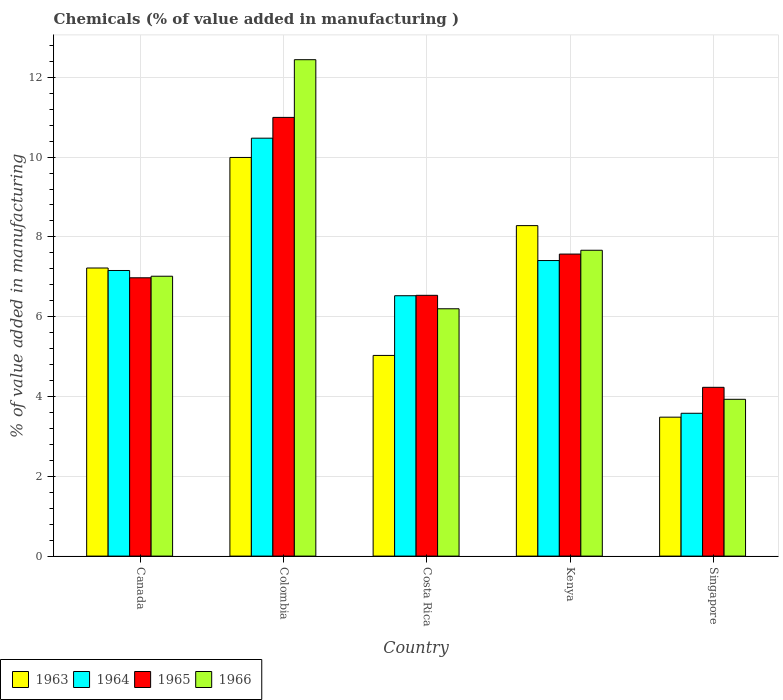How many groups of bars are there?
Your answer should be very brief. 5. Are the number of bars on each tick of the X-axis equal?
Your answer should be compact. Yes. How many bars are there on the 4th tick from the right?
Provide a short and direct response. 4. What is the label of the 5th group of bars from the left?
Offer a terse response. Singapore. In how many cases, is the number of bars for a given country not equal to the number of legend labels?
Your answer should be compact. 0. What is the value added in manufacturing chemicals in 1964 in Canada?
Your answer should be compact. 7.16. Across all countries, what is the maximum value added in manufacturing chemicals in 1966?
Ensure brevity in your answer.  12.44. Across all countries, what is the minimum value added in manufacturing chemicals in 1966?
Your response must be concise. 3.93. In which country was the value added in manufacturing chemicals in 1963 minimum?
Keep it short and to the point. Singapore. What is the total value added in manufacturing chemicals in 1964 in the graph?
Keep it short and to the point. 35.15. What is the difference between the value added in manufacturing chemicals in 1965 in Costa Rica and that in Kenya?
Your answer should be compact. -1.03. What is the difference between the value added in manufacturing chemicals in 1963 in Costa Rica and the value added in manufacturing chemicals in 1965 in Colombia?
Keep it short and to the point. -5.97. What is the average value added in manufacturing chemicals in 1964 per country?
Offer a very short reply. 7.03. What is the difference between the value added in manufacturing chemicals of/in 1963 and value added in manufacturing chemicals of/in 1966 in Singapore?
Your response must be concise. -0.45. In how many countries, is the value added in manufacturing chemicals in 1965 greater than 11.2 %?
Your answer should be compact. 0. What is the ratio of the value added in manufacturing chemicals in 1966 in Kenya to that in Singapore?
Provide a short and direct response. 1.95. Is the value added in manufacturing chemicals in 1966 in Colombia less than that in Singapore?
Provide a succinct answer. No. Is the difference between the value added in manufacturing chemicals in 1963 in Canada and Colombia greater than the difference between the value added in manufacturing chemicals in 1966 in Canada and Colombia?
Your answer should be very brief. Yes. What is the difference between the highest and the second highest value added in manufacturing chemicals in 1966?
Make the answer very short. -5.43. What is the difference between the highest and the lowest value added in manufacturing chemicals in 1963?
Keep it short and to the point. 6.51. In how many countries, is the value added in manufacturing chemicals in 1965 greater than the average value added in manufacturing chemicals in 1965 taken over all countries?
Offer a terse response. 2. Is the sum of the value added in manufacturing chemicals in 1964 in Kenya and Singapore greater than the maximum value added in manufacturing chemicals in 1966 across all countries?
Your response must be concise. No. What does the 3rd bar from the left in Kenya represents?
Your response must be concise. 1965. What does the 2nd bar from the right in Singapore represents?
Keep it short and to the point. 1965. How many bars are there?
Keep it short and to the point. 20. What is the difference between two consecutive major ticks on the Y-axis?
Your answer should be very brief. 2. Are the values on the major ticks of Y-axis written in scientific E-notation?
Offer a terse response. No. Does the graph contain any zero values?
Give a very brief answer. No. Does the graph contain grids?
Provide a succinct answer. Yes. What is the title of the graph?
Your answer should be compact. Chemicals (% of value added in manufacturing ). Does "1972" appear as one of the legend labels in the graph?
Your answer should be compact. No. What is the label or title of the X-axis?
Make the answer very short. Country. What is the label or title of the Y-axis?
Keep it short and to the point. % of value added in manufacturing. What is the % of value added in manufacturing of 1963 in Canada?
Provide a succinct answer. 7.22. What is the % of value added in manufacturing of 1964 in Canada?
Your response must be concise. 7.16. What is the % of value added in manufacturing of 1965 in Canada?
Your answer should be compact. 6.98. What is the % of value added in manufacturing of 1966 in Canada?
Ensure brevity in your answer.  7.01. What is the % of value added in manufacturing of 1963 in Colombia?
Your response must be concise. 9.99. What is the % of value added in manufacturing in 1964 in Colombia?
Give a very brief answer. 10.47. What is the % of value added in manufacturing in 1965 in Colombia?
Your answer should be very brief. 10.99. What is the % of value added in manufacturing of 1966 in Colombia?
Give a very brief answer. 12.44. What is the % of value added in manufacturing in 1963 in Costa Rica?
Your response must be concise. 5.03. What is the % of value added in manufacturing in 1964 in Costa Rica?
Give a very brief answer. 6.53. What is the % of value added in manufacturing of 1965 in Costa Rica?
Your answer should be compact. 6.54. What is the % of value added in manufacturing in 1966 in Costa Rica?
Your answer should be compact. 6.2. What is the % of value added in manufacturing in 1963 in Kenya?
Make the answer very short. 8.28. What is the % of value added in manufacturing in 1964 in Kenya?
Your answer should be compact. 7.41. What is the % of value added in manufacturing in 1965 in Kenya?
Keep it short and to the point. 7.57. What is the % of value added in manufacturing of 1966 in Kenya?
Make the answer very short. 7.67. What is the % of value added in manufacturing of 1963 in Singapore?
Ensure brevity in your answer.  3.48. What is the % of value added in manufacturing of 1964 in Singapore?
Your answer should be very brief. 3.58. What is the % of value added in manufacturing of 1965 in Singapore?
Give a very brief answer. 4.23. What is the % of value added in manufacturing in 1966 in Singapore?
Provide a succinct answer. 3.93. Across all countries, what is the maximum % of value added in manufacturing of 1963?
Provide a succinct answer. 9.99. Across all countries, what is the maximum % of value added in manufacturing of 1964?
Your response must be concise. 10.47. Across all countries, what is the maximum % of value added in manufacturing in 1965?
Your response must be concise. 10.99. Across all countries, what is the maximum % of value added in manufacturing in 1966?
Offer a terse response. 12.44. Across all countries, what is the minimum % of value added in manufacturing of 1963?
Your answer should be compact. 3.48. Across all countries, what is the minimum % of value added in manufacturing in 1964?
Make the answer very short. 3.58. Across all countries, what is the minimum % of value added in manufacturing of 1965?
Make the answer very short. 4.23. Across all countries, what is the minimum % of value added in manufacturing in 1966?
Give a very brief answer. 3.93. What is the total % of value added in manufacturing of 1963 in the graph?
Provide a succinct answer. 34.01. What is the total % of value added in manufacturing of 1964 in the graph?
Make the answer very short. 35.15. What is the total % of value added in manufacturing of 1965 in the graph?
Ensure brevity in your answer.  36.31. What is the total % of value added in manufacturing in 1966 in the graph?
Ensure brevity in your answer.  37.25. What is the difference between the % of value added in manufacturing in 1963 in Canada and that in Colombia?
Your answer should be very brief. -2.77. What is the difference between the % of value added in manufacturing in 1964 in Canada and that in Colombia?
Ensure brevity in your answer.  -3.32. What is the difference between the % of value added in manufacturing in 1965 in Canada and that in Colombia?
Keep it short and to the point. -4.02. What is the difference between the % of value added in manufacturing of 1966 in Canada and that in Colombia?
Ensure brevity in your answer.  -5.43. What is the difference between the % of value added in manufacturing of 1963 in Canada and that in Costa Rica?
Offer a very short reply. 2.19. What is the difference between the % of value added in manufacturing in 1964 in Canada and that in Costa Rica?
Your response must be concise. 0.63. What is the difference between the % of value added in manufacturing of 1965 in Canada and that in Costa Rica?
Your answer should be very brief. 0.44. What is the difference between the % of value added in manufacturing in 1966 in Canada and that in Costa Rica?
Your answer should be compact. 0.82. What is the difference between the % of value added in manufacturing of 1963 in Canada and that in Kenya?
Make the answer very short. -1.06. What is the difference between the % of value added in manufacturing in 1964 in Canada and that in Kenya?
Your answer should be compact. -0.25. What is the difference between the % of value added in manufacturing in 1965 in Canada and that in Kenya?
Make the answer very short. -0.59. What is the difference between the % of value added in manufacturing in 1966 in Canada and that in Kenya?
Offer a terse response. -0.65. What is the difference between the % of value added in manufacturing in 1963 in Canada and that in Singapore?
Ensure brevity in your answer.  3.74. What is the difference between the % of value added in manufacturing of 1964 in Canada and that in Singapore?
Ensure brevity in your answer.  3.58. What is the difference between the % of value added in manufacturing of 1965 in Canada and that in Singapore?
Provide a succinct answer. 2.75. What is the difference between the % of value added in manufacturing of 1966 in Canada and that in Singapore?
Offer a terse response. 3.08. What is the difference between the % of value added in manufacturing in 1963 in Colombia and that in Costa Rica?
Keep it short and to the point. 4.96. What is the difference between the % of value added in manufacturing of 1964 in Colombia and that in Costa Rica?
Provide a succinct answer. 3.95. What is the difference between the % of value added in manufacturing in 1965 in Colombia and that in Costa Rica?
Offer a terse response. 4.46. What is the difference between the % of value added in manufacturing of 1966 in Colombia and that in Costa Rica?
Offer a terse response. 6.24. What is the difference between the % of value added in manufacturing in 1963 in Colombia and that in Kenya?
Your answer should be very brief. 1.71. What is the difference between the % of value added in manufacturing in 1964 in Colombia and that in Kenya?
Offer a terse response. 3.07. What is the difference between the % of value added in manufacturing in 1965 in Colombia and that in Kenya?
Keep it short and to the point. 3.43. What is the difference between the % of value added in manufacturing in 1966 in Colombia and that in Kenya?
Give a very brief answer. 4.78. What is the difference between the % of value added in manufacturing of 1963 in Colombia and that in Singapore?
Provide a short and direct response. 6.51. What is the difference between the % of value added in manufacturing in 1964 in Colombia and that in Singapore?
Give a very brief answer. 6.89. What is the difference between the % of value added in manufacturing in 1965 in Colombia and that in Singapore?
Offer a very short reply. 6.76. What is the difference between the % of value added in manufacturing of 1966 in Colombia and that in Singapore?
Make the answer very short. 8.51. What is the difference between the % of value added in manufacturing of 1963 in Costa Rica and that in Kenya?
Offer a very short reply. -3.25. What is the difference between the % of value added in manufacturing in 1964 in Costa Rica and that in Kenya?
Make the answer very short. -0.88. What is the difference between the % of value added in manufacturing in 1965 in Costa Rica and that in Kenya?
Give a very brief answer. -1.03. What is the difference between the % of value added in manufacturing in 1966 in Costa Rica and that in Kenya?
Your answer should be very brief. -1.47. What is the difference between the % of value added in manufacturing in 1963 in Costa Rica and that in Singapore?
Keep it short and to the point. 1.55. What is the difference between the % of value added in manufacturing of 1964 in Costa Rica and that in Singapore?
Offer a very short reply. 2.95. What is the difference between the % of value added in manufacturing in 1965 in Costa Rica and that in Singapore?
Offer a very short reply. 2.31. What is the difference between the % of value added in manufacturing in 1966 in Costa Rica and that in Singapore?
Offer a very short reply. 2.27. What is the difference between the % of value added in manufacturing in 1963 in Kenya and that in Singapore?
Ensure brevity in your answer.  4.8. What is the difference between the % of value added in manufacturing of 1964 in Kenya and that in Singapore?
Keep it short and to the point. 3.83. What is the difference between the % of value added in manufacturing in 1965 in Kenya and that in Singapore?
Offer a terse response. 3.34. What is the difference between the % of value added in manufacturing of 1966 in Kenya and that in Singapore?
Your answer should be compact. 3.74. What is the difference between the % of value added in manufacturing of 1963 in Canada and the % of value added in manufacturing of 1964 in Colombia?
Your answer should be compact. -3.25. What is the difference between the % of value added in manufacturing of 1963 in Canada and the % of value added in manufacturing of 1965 in Colombia?
Make the answer very short. -3.77. What is the difference between the % of value added in manufacturing in 1963 in Canada and the % of value added in manufacturing in 1966 in Colombia?
Provide a short and direct response. -5.22. What is the difference between the % of value added in manufacturing of 1964 in Canada and the % of value added in manufacturing of 1965 in Colombia?
Your answer should be very brief. -3.84. What is the difference between the % of value added in manufacturing in 1964 in Canada and the % of value added in manufacturing in 1966 in Colombia?
Your response must be concise. -5.28. What is the difference between the % of value added in manufacturing of 1965 in Canada and the % of value added in manufacturing of 1966 in Colombia?
Ensure brevity in your answer.  -5.47. What is the difference between the % of value added in manufacturing in 1963 in Canada and the % of value added in manufacturing in 1964 in Costa Rica?
Your answer should be compact. 0.69. What is the difference between the % of value added in manufacturing of 1963 in Canada and the % of value added in manufacturing of 1965 in Costa Rica?
Make the answer very short. 0.68. What is the difference between the % of value added in manufacturing of 1963 in Canada and the % of value added in manufacturing of 1966 in Costa Rica?
Keep it short and to the point. 1.02. What is the difference between the % of value added in manufacturing of 1964 in Canada and the % of value added in manufacturing of 1965 in Costa Rica?
Your response must be concise. 0.62. What is the difference between the % of value added in manufacturing of 1964 in Canada and the % of value added in manufacturing of 1966 in Costa Rica?
Your answer should be compact. 0.96. What is the difference between the % of value added in manufacturing of 1965 in Canada and the % of value added in manufacturing of 1966 in Costa Rica?
Keep it short and to the point. 0.78. What is the difference between the % of value added in manufacturing of 1963 in Canada and the % of value added in manufacturing of 1964 in Kenya?
Provide a short and direct response. -0.19. What is the difference between the % of value added in manufacturing of 1963 in Canada and the % of value added in manufacturing of 1965 in Kenya?
Offer a terse response. -0.35. What is the difference between the % of value added in manufacturing of 1963 in Canada and the % of value added in manufacturing of 1966 in Kenya?
Make the answer very short. -0.44. What is the difference between the % of value added in manufacturing in 1964 in Canada and the % of value added in manufacturing in 1965 in Kenya?
Offer a very short reply. -0.41. What is the difference between the % of value added in manufacturing of 1964 in Canada and the % of value added in manufacturing of 1966 in Kenya?
Make the answer very short. -0.51. What is the difference between the % of value added in manufacturing in 1965 in Canada and the % of value added in manufacturing in 1966 in Kenya?
Offer a terse response. -0.69. What is the difference between the % of value added in manufacturing of 1963 in Canada and the % of value added in manufacturing of 1964 in Singapore?
Ensure brevity in your answer.  3.64. What is the difference between the % of value added in manufacturing of 1963 in Canada and the % of value added in manufacturing of 1965 in Singapore?
Offer a very short reply. 2.99. What is the difference between the % of value added in manufacturing in 1963 in Canada and the % of value added in manufacturing in 1966 in Singapore?
Provide a succinct answer. 3.29. What is the difference between the % of value added in manufacturing of 1964 in Canada and the % of value added in manufacturing of 1965 in Singapore?
Keep it short and to the point. 2.93. What is the difference between the % of value added in manufacturing in 1964 in Canada and the % of value added in manufacturing in 1966 in Singapore?
Provide a short and direct response. 3.23. What is the difference between the % of value added in manufacturing in 1965 in Canada and the % of value added in manufacturing in 1966 in Singapore?
Provide a short and direct response. 3.05. What is the difference between the % of value added in manufacturing in 1963 in Colombia and the % of value added in manufacturing in 1964 in Costa Rica?
Offer a terse response. 3.47. What is the difference between the % of value added in manufacturing in 1963 in Colombia and the % of value added in manufacturing in 1965 in Costa Rica?
Keep it short and to the point. 3.46. What is the difference between the % of value added in manufacturing in 1963 in Colombia and the % of value added in manufacturing in 1966 in Costa Rica?
Your response must be concise. 3.79. What is the difference between the % of value added in manufacturing of 1964 in Colombia and the % of value added in manufacturing of 1965 in Costa Rica?
Provide a succinct answer. 3.94. What is the difference between the % of value added in manufacturing of 1964 in Colombia and the % of value added in manufacturing of 1966 in Costa Rica?
Give a very brief answer. 4.28. What is the difference between the % of value added in manufacturing of 1965 in Colombia and the % of value added in manufacturing of 1966 in Costa Rica?
Make the answer very short. 4.8. What is the difference between the % of value added in manufacturing of 1963 in Colombia and the % of value added in manufacturing of 1964 in Kenya?
Your answer should be very brief. 2.58. What is the difference between the % of value added in manufacturing in 1963 in Colombia and the % of value added in manufacturing in 1965 in Kenya?
Your answer should be very brief. 2.42. What is the difference between the % of value added in manufacturing in 1963 in Colombia and the % of value added in manufacturing in 1966 in Kenya?
Ensure brevity in your answer.  2.33. What is the difference between the % of value added in manufacturing of 1964 in Colombia and the % of value added in manufacturing of 1965 in Kenya?
Provide a succinct answer. 2.9. What is the difference between the % of value added in manufacturing in 1964 in Colombia and the % of value added in manufacturing in 1966 in Kenya?
Your answer should be compact. 2.81. What is the difference between the % of value added in manufacturing in 1965 in Colombia and the % of value added in manufacturing in 1966 in Kenya?
Offer a terse response. 3.33. What is the difference between the % of value added in manufacturing in 1963 in Colombia and the % of value added in manufacturing in 1964 in Singapore?
Your answer should be very brief. 6.41. What is the difference between the % of value added in manufacturing of 1963 in Colombia and the % of value added in manufacturing of 1965 in Singapore?
Your response must be concise. 5.76. What is the difference between the % of value added in manufacturing of 1963 in Colombia and the % of value added in manufacturing of 1966 in Singapore?
Offer a very short reply. 6.06. What is the difference between the % of value added in manufacturing in 1964 in Colombia and the % of value added in manufacturing in 1965 in Singapore?
Offer a very short reply. 6.24. What is the difference between the % of value added in manufacturing in 1964 in Colombia and the % of value added in manufacturing in 1966 in Singapore?
Give a very brief answer. 6.54. What is the difference between the % of value added in manufacturing of 1965 in Colombia and the % of value added in manufacturing of 1966 in Singapore?
Keep it short and to the point. 7.07. What is the difference between the % of value added in manufacturing of 1963 in Costa Rica and the % of value added in manufacturing of 1964 in Kenya?
Ensure brevity in your answer.  -2.38. What is the difference between the % of value added in manufacturing of 1963 in Costa Rica and the % of value added in manufacturing of 1965 in Kenya?
Your response must be concise. -2.54. What is the difference between the % of value added in manufacturing of 1963 in Costa Rica and the % of value added in manufacturing of 1966 in Kenya?
Your answer should be very brief. -2.64. What is the difference between the % of value added in manufacturing in 1964 in Costa Rica and the % of value added in manufacturing in 1965 in Kenya?
Your answer should be very brief. -1.04. What is the difference between the % of value added in manufacturing in 1964 in Costa Rica and the % of value added in manufacturing in 1966 in Kenya?
Your response must be concise. -1.14. What is the difference between the % of value added in manufacturing of 1965 in Costa Rica and the % of value added in manufacturing of 1966 in Kenya?
Provide a short and direct response. -1.13. What is the difference between the % of value added in manufacturing in 1963 in Costa Rica and the % of value added in manufacturing in 1964 in Singapore?
Ensure brevity in your answer.  1.45. What is the difference between the % of value added in manufacturing of 1963 in Costa Rica and the % of value added in manufacturing of 1965 in Singapore?
Your answer should be compact. 0.8. What is the difference between the % of value added in manufacturing in 1963 in Costa Rica and the % of value added in manufacturing in 1966 in Singapore?
Ensure brevity in your answer.  1.1. What is the difference between the % of value added in manufacturing in 1964 in Costa Rica and the % of value added in manufacturing in 1965 in Singapore?
Provide a succinct answer. 2.3. What is the difference between the % of value added in manufacturing in 1964 in Costa Rica and the % of value added in manufacturing in 1966 in Singapore?
Ensure brevity in your answer.  2.6. What is the difference between the % of value added in manufacturing of 1965 in Costa Rica and the % of value added in manufacturing of 1966 in Singapore?
Give a very brief answer. 2.61. What is the difference between the % of value added in manufacturing of 1963 in Kenya and the % of value added in manufacturing of 1964 in Singapore?
Your answer should be compact. 4.7. What is the difference between the % of value added in manufacturing in 1963 in Kenya and the % of value added in manufacturing in 1965 in Singapore?
Offer a terse response. 4.05. What is the difference between the % of value added in manufacturing in 1963 in Kenya and the % of value added in manufacturing in 1966 in Singapore?
Your answer should be very brief. 4.35. What is the difference between the % of value added in manufacturing of 1964 in Kenya and the % of value added in manufacturing of 1965 in Singapore?
Your response must be concise. 3.18. What is the difference between the % of value added in manufacturing of 1964 in Kenya and the % of value added in manufacturing of 1966 in Singapore?
Provide a short and direct response. 3.48. What is the difference between the % of value added in manufacturing in 1965 in Kenya and the % of value added in manufacturing in 1966 in Singapore?
Provide a short and direct response. 3.64. What is the average % of value added in manufacturing of 1963 per country?
Your answer should be compact. 6.8. What is the average % of value added in manufacturing of 1964 per country?
Give a very brief answer. 7.03. What is the average % of value added in manufacturing of 1965 per country?
Ensure brevity in your answer.  7.26. What is the average % of value added in manufacturing of 1966 per country?
Give a very brief answer. 7.45. What is the difference between the % of value added in manufacturing of 1963 and % of value added in manufacturing of 1964 in Canada?
Your answer should be compact. 0.06. What is the difference between the % of value added in manufacturing in 1963 and % of value added in manufacturing in 1965 in Canada?
Keep it short and to the point. 0.25. What is the difference between the % of value added in manufacturing of 1963 and % of value added in manufacturing of 1966 in Canada?
Your answer should be compact. 0.21. What is the difference between the % of value added in manufacturing of 1964 and % of value added in manufacturing of 1965 in Canada?
Provide a succinct answer. 0.18. What is the difference between the % of value added in manufacturing in 1964 and % of value added in manufacturing in 1966 in Canada?
Provide a short and direct response. 0.14. What is the difference between the % of value added in manufacturing of 1965 and % of value added in manufacturing of 1966 in Canada?
Your answer should be very brief. -0.04. What is the difference between the % of value added in manufacturing of 1963 and % of value added in manufacturing of 1964 in Colombia?
Provide a short and direct response. -0.48. What is the difference between the % of value added in manufacturing of 1963 and % of value added in manufacturing of 1965 in Colombia?
Your answer should be compact. -1. What is the difference between the % of value added in manufacturing in 1963 and % of value added in manufacturing in 1966 in Colombia?
Provide a succinct answer. -2.45. What is the difference between the % of value added in manufacturing of 1964 and % of value added in manufacturing of 1965 in Colombia?
Provide a succinct answer. -0.52. What is the difference between the % of value added in manufacturing of 1964 and % of value added in manufacturing of 1966 in Colombia?
Offer a terse response. -1.97. What is the difference between the % of value added in manufacturing of 1965 and % of value added in manufacturing of 1966 in Colombia?
Your answer should be compact. -1.45. What is the difference between the % of value added in manufacturing of 1963 and % of value added in manufacturing of 1964 in Costa Rica?
Keep it short and to the point. -1.5. What is the difference between the % of value added in manufacturing in 1963 and % of value added in manufacturing in 1965 in Costa Rica?
Ensure brevity in your answer.  -1.51. What is the difference between the % of value added in manufacturing in 1963 and % of value added in manufacturing in 1966 in Costa Rica?
Offer a terse response. -1.17. What is the difference between the % of value added in manufacturing in 1964 and % of value added in manufacturing in 1965 in Costa Rica?
Your response must be concise. -0.01. What is the difference between the % of value added in manufacturing of 1964 and % of value added in manufacturing of 1966 in Costa Rica?
Make the answer very short. 0.33. What is the difference between the % of value added in manufacturing in 1965 and % of value added in manufacturing in 1966 in Costa Rica?
Ensure brevity in your answer.  0.34. What is the difference between the % of value added in manufacturing of 1963 and % of value added in manufacturing of 1964 in Kenya?
Keep it short and to the point. 0.87. What is the difference between the % of value added in manufacturing of 1963 and % of value added in manufacturing of 1965 in Kenya?
Make the answer very short. 0.71. What is the difference between the % of value added in manufacturing in 1963 and % of value added in manufacturing in 1966 in Kenya?
Provide a short and direct response. 0.62. What is the difference between the % of value added in manufacturing of 1964 and % of value added in manufacturing of 1965 in Kenya?
Keep it short and to the point. -0.16. What is the difference between the % of value added in manufacturing of 1964 and % of value added in manufacturing of 1966 in Kenya?
Make the answer very short. -0.26. What is the difference between the % of value added in manufacturing of 1965 and % of value added in manufacturing of 1966 in Kenya?
Give a very brief answer. -0.1. What is the difference between the % of value added in manufacturing of 1963 and % of value added in manufacturing of 1964 in Singapore?
Your answer should be compact. -0.1. What is the difference between the % of value added in manufacturing in 1963 and % of value added in manufacturing in 1965 in Singapore?
Give a very brief answer. -0.75. What is the difference between the % of value added in manufacturing of 1963 and % of value added in manufacturing of 1966 in Singapore?
Offer a terse response. -0.45. What is the difference between the % of value added in manufacturing of 1964 and % of value added in manufacturing of 1965 in Singapore?
Offer a terse response. -0.65. What is the difference between the % of value added in manufacturing in 1964 and % of value added in manufacturing in 1966 in Singapore?
Offer a terse response. -0.35. What is the difference between the % of value added in manufacturing of 1965 and % of value added in manufacturing of 1966 in Singapore?
Your response must be concise. 0.3. What is the ratio of the % of value added in manufacturing in 1963 in Canada to that in Colombia?
Provide a succinct answer. 0.72. What is the ratio of the % of value added in manufacturing in 1964 in Canada to that in Colombia?
Keep it short and to the point. 0.68. What is the ratio of the % of value added in manufacturing of 1965 in Canada to that in Colombia?
Your answer should be very brief. 0.63. What is the ratio of the % of value added in manufacturing in 1966 in Canada to that in Colombia?
Make the answer very short. 0.56. What is the ratio of the % of value added in manufacturing of 1963 in Canada to that in Costa Rica?
Keep it short and to the point. 1.44. What is the ratio of the % of value added in manufacturing in 1964 in Canada to that in Costa Rica?
Ensure brevity in your answer.  1.1. What is the ratio of the % of value added in manufacturing in 1965 in Canada to that in Costa Rica?
Offer a very short reply. 1.07. What is the ratio of the % of value added in manufacturing of 1966 in Canada to that in Costa Rica?
Offer a very short reply. 1.13. What is the ratio of the % of value added in manufacturing of 1963 in Canada to that in Kenya?
Provide a succinct answer. 0.87. What is the ratio of the % of value added in manufacturing in 1964 in Canada to that in Kenya?
Provide a succinct answer. 0.97. What is the ratio of the % of value added in manufacturing in 1965 in Canada to that in Kenya?
Offer a very short reply. 0.92. What is the ratio of the % of value added in manufacturing in 1966 in Canada to that in Kenya?
Ensure brevity in your answer.  0.92. What is the ratio of the % of value added in manufacturing of 1963 in Canada to that in Singapore?
Make the answer very short. 2.07. What is the ratio of the % of value added in manufacturing of 1964 in Canada to that in Singapore?
Provide a succinct answer. 2. What is the ratio of the % of value added in manufacturing of 1965 in Canada to that in Singapore?
Your answer should be very brief. 1.65. What is the ratio of the % of value added in manufacturing in 1966 in Canada to that in Singapore?
Your response must be concise. 1.78. What is the ratio of the % of value added in manufacturing in 1963 in Colombia to that in Costa Rica?
Provide a short and direct response. 1.99. What is the ratio of the % of value added in manufacturing of 1964 in Colombia to that in Costa Rica?
Ensure brevity in your answer.  1.61. What is the ratio of the % of value added in manufacturing of 1965 in Colombia to that in Costa Rica?
Keep it short and to the point. 1.68. What is the ratio of the % of value added in manufacturing of 1966 in Colombia to that in Costa Rica?
Your answer should be compact. 2.01. What is the ratio of the % of value added in manufacturing in 1963 in Colombia to that in Kenya?
Provide a succinct answer. 1.21. What is the ratio of the % of value added in manufacturing of 1964 in Colombia to that in Kenya?
Your response must be concise. 1.41. What is the ratio of the % of value added in manufacturing in 1965 in Colombia to that in Kenya?
Offer a terse response. 1.45. What is the ratio of the % of value added in manufacturing in 1966 in Colombia to that in Kenya?
Your answer should be compact. 1.62. What is the ratio of the % of value added in manufacturing in 1963 in Colombia to that in Singapore?
Give a very brief answer. 2.87. What is the ratio of the % of value added in manufacturing of 1964 in Colombia to that in Singapore?
Offer a terse response. 2.93. What is the ratio of the % of value added in manufacturing in 1965 in Colombia to that in Singapore?
Offer a very short reply. 2.6. What is the ratio of the % of value added in manufacturing in 1966 in Colombia to that in Singapore?
Keep it short and to the point. 3.17. What is the ratio of the % of value added in manufacturing in 1963 in Costa Rica to that in Kenya?
Keep it short and to the point. 0.61. What is the ratio of the % of value added in manufacturing of 1964 in Costa Rica to that in Kenya?
Your response must be concise. 0.88. What is the ratio of the % of value added in manufacturing in 1965 in Costa Rica to that in Kenya?
Provide a succinct answer. 0.86. What is the ratio of the % of value added in manufacturing of 1966 in Costa Rica to that in Kenya?
Provide a succinct answer. 0.81. What is the ratio of the % of value added in manufacturing of 1963 in Costa Rica to that in Singapore?
Your answer should be compact. 1.44. What is the ratio of the % of value added in manufacturing of 1964 in Costa Rica to that in Singapore?
Make the answer very short. 1.82. What is the ratio of the % of value added in manufacturing of 1965 in Costa Rica to that in Singapore?
Provide a short and direct response. 1.55. What is the ratio of the % of value added in manufacturing in 1966 in Costa Rica to that in Singapore?
Keep it short and to the point. 1.58. What is the ratio of the % of value added in manufacturing in 1963 in Kenya to that in Singapore?
Make the answer very short. 2.38. What is the ratio of the % of value added in manufacturing of 1964 in Kenya to that in Singapore?
Your answer should be very brief. 2.07. What is the ratio of the % of value added in manufacturing of 1965 in Kenya to that in Singapore?
Offer a terse response. 1.79. What is the ratio of the % of value added in manufacturing in 1966 in Kenya to that in Singapore?
Your answer should be compact. 1.95. What is the difference between the highest and the second highest % of value added in manufacturing in 1963?
Provide a short and direct response. 1.71. What is the difference between the highest and the second highest % of value added in manufacturing of 1964?
Your answer should be compact. 3.07. What is the difference between the highest and the second highest % of value added in manufacturing of 1965?
Offer a terse response. 3.43. What is the difference between the highest and the second highest % of value added in manufacturing in 1966?
Keep it short and to the point. 4.78. What is the difference between the highest and the lowest % of value added in manufacturing of 1963?
Your answer should be compact. 6.51. What is the difference between the highest and the lowest % of value added in manufacturing of 1964?
Keep it short and to the point. 6.89. What is the difference between the highest and the lowest % of value added in manufacturing of 1965?
Keep it short and to the point. 6.76. What is the difference between the highest and the lowest % of value added in manufacturing in 1966?
Ensure brevity in your answer.  8.51. 